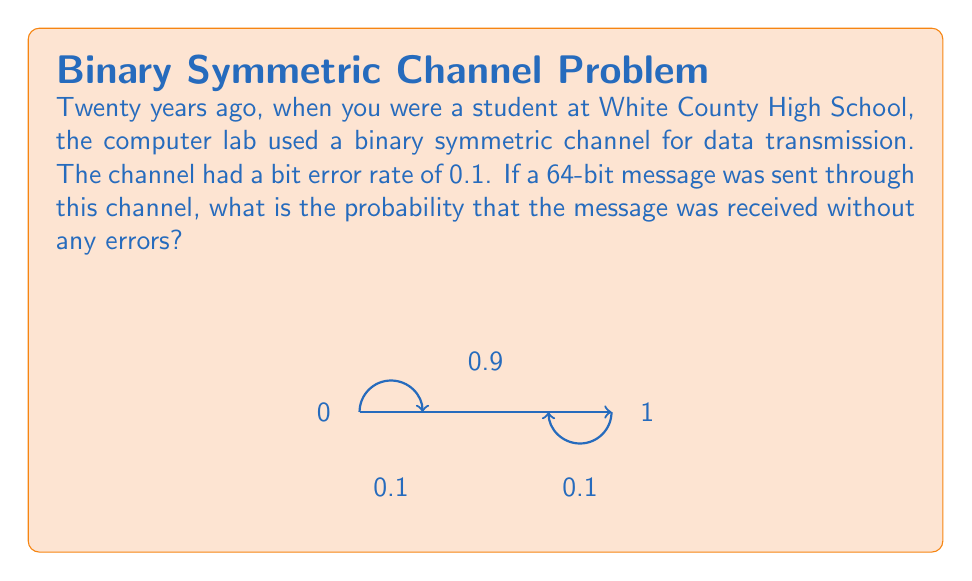Could you help me with this problem? Let's approach this step-by-step:

1) In a binary symmetric channel, each bit has a probability of being transmitted correctly or incorrectly. The probability of a bit error is given as 0.1.

2) Therefore, the probability of a bit being transmitted correctly is 1 - 0.1 = 0.9.

3) For the entire message to be received without errors, each of the 64 bits must be transmitted correctly.

4) The probability of all bits being correct is the product of the individual probabilities, as these are independent events.

5) We can express this mathematically as:

   $$P(\text{no errors}) = (0.9)^{64}$$

6) To calculate this:
   
   $$P(\text{no errors}) = (0.9)^{64} \approx 0.001083$$

7) We can convert this to a percentage:

   $$0.001083 \times 100\% \approx 0.1083\%$$

Thus, there is approximately a 0.1083% chance that the 64-bit message was received without any errors.
Answer: $0.1083\%$ 